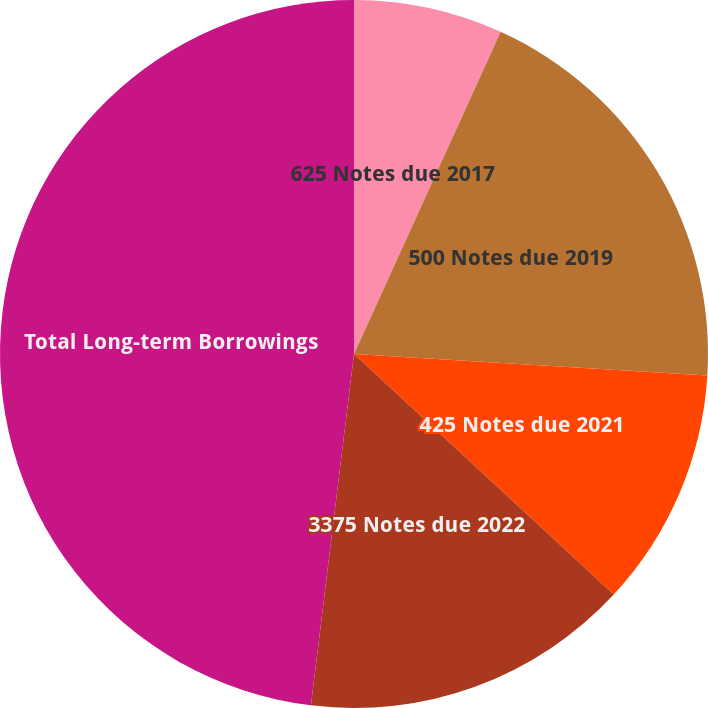Convert chart. <chart><loc_0><loc_0><loc_500><loc_500><pie_chart><fcel>625 Notes due 2017<fcel>500 Notes due 2019<fcel>425 Notes due 2021<fcel>3375 Notes due 2022<fcel>Total Long-term Borrowings<nl><fcel>6.8%<fcel>19.17%<fcel>10.92%<fcel>15.05%<fcel>48.06%<nl></chart> 